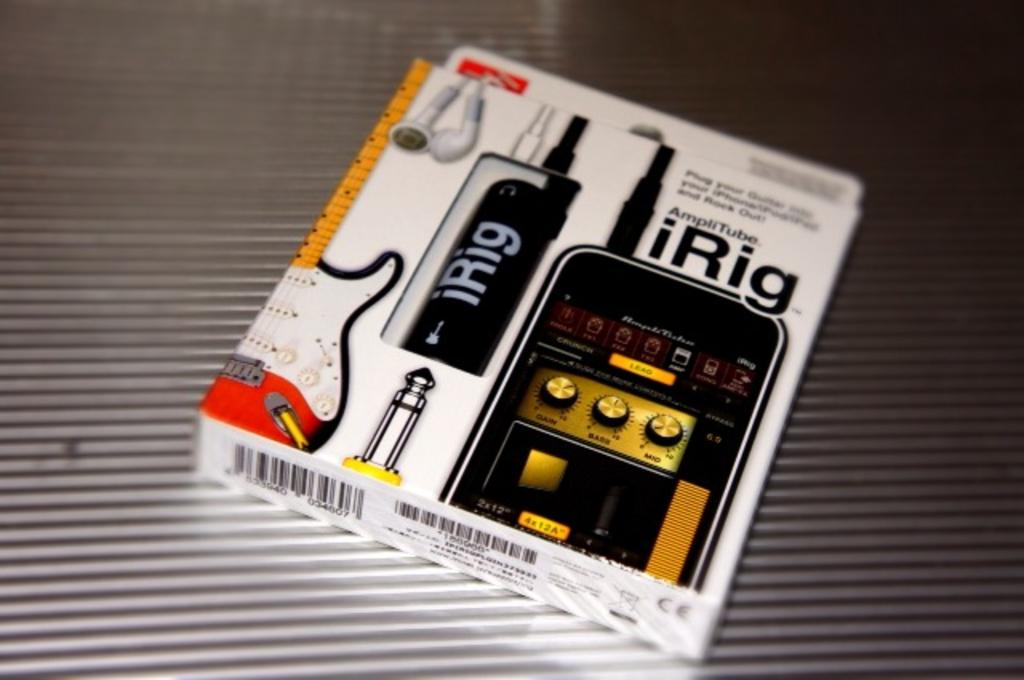<image>
Offer a succinct explanation of the picture presented. A cord that acts as an adapter that attaches to an Iphone. 